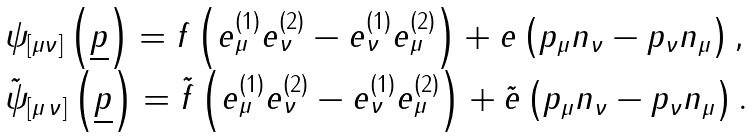<formula> <loc_0><loc_0><loc_500><loc_500>\begin{array} { l } \psi _ { \left [ { \mu \nu } \right ] } \left ( { \underline { p } } \right ) = f \left ( { e _ { \mu } ^ { \left ( 1 \right ) } e _ { \nu } ^ { \left ( 2 \right ) } - e _ { \nu } ^ { \left ( 1 \right ) } e _ { \mu } ^ { \left ( 2 \right ) } } \right ) + e \left ( { p _ { \mu } n _ { \nu } - p _ { \nu } n _ { \mu } } \right ) , \\ \tilde { \psi } _ { \left [ { \mu \, \nu } \right ] } \left ( { \underline { p } } \right ) = \tilde { f } \left ( { e _ { \mu } ^ { \left ( 1 \right ) } e _ { \nu } ^ { \left ( 2 \right ) } - e _ { \nu } ^ { \left ( 1 \right ) } e _ { \mu } ^ { \left ( 2 \right ) } } \right ) + \tilde { e } \left ( { p _ { \mu } n _ { \nu } - p _ { \nu } n _ { \mu } } \right ) . \end{array}</formula> 